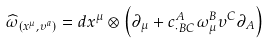<formula> <loc_0><loc_0><loc_500><loc_500>\widehat { \omega } _ { \left ( x ^ { \mu } , \upsilon ^ { a } \right ) } = d x ^ { \mu } \otimes \left ( \partial _ { \mu } + c _ { \cdot B C } ^ { A } \omega _ { \mu } ^ { B } \upsilon ^ { C } \partial _ { A } \right )</formula> 